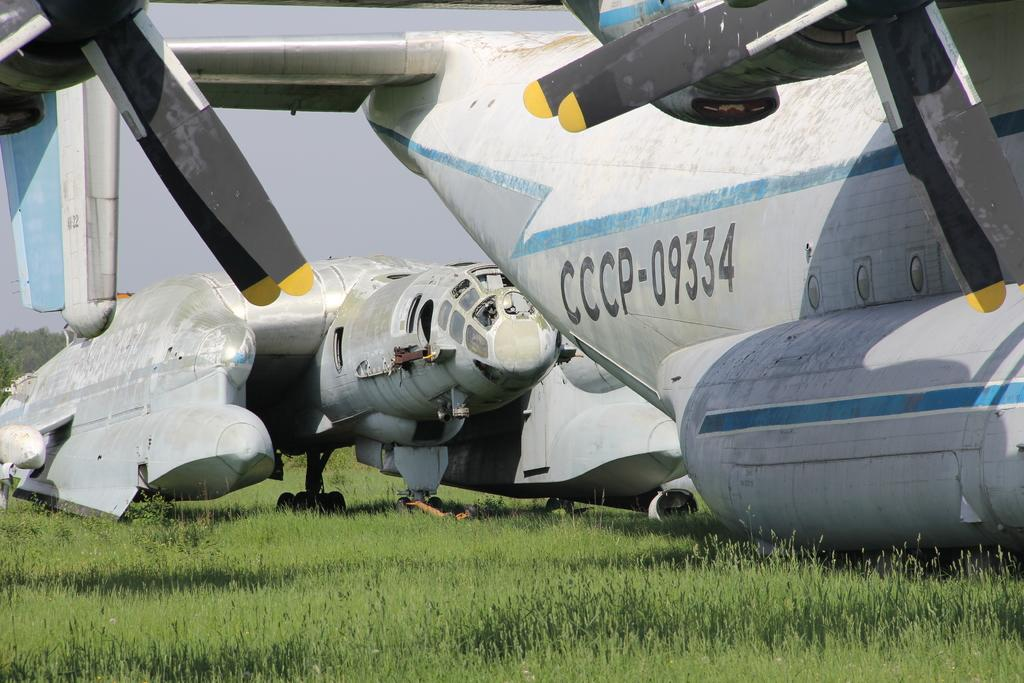<image>
Share a concise interpretation of the image provided. Two large aeroplanes, one carrying the identification CCCP-09334 sit in a field. 